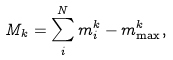Convert formula to latex. <formula><loc_0><loc_0><loc_500><loc_500>M _ { k } = \sum _ { i } ^ { N } m _ { i } ^ { k } - m _ { \max } ^ { k } ,</formula> 